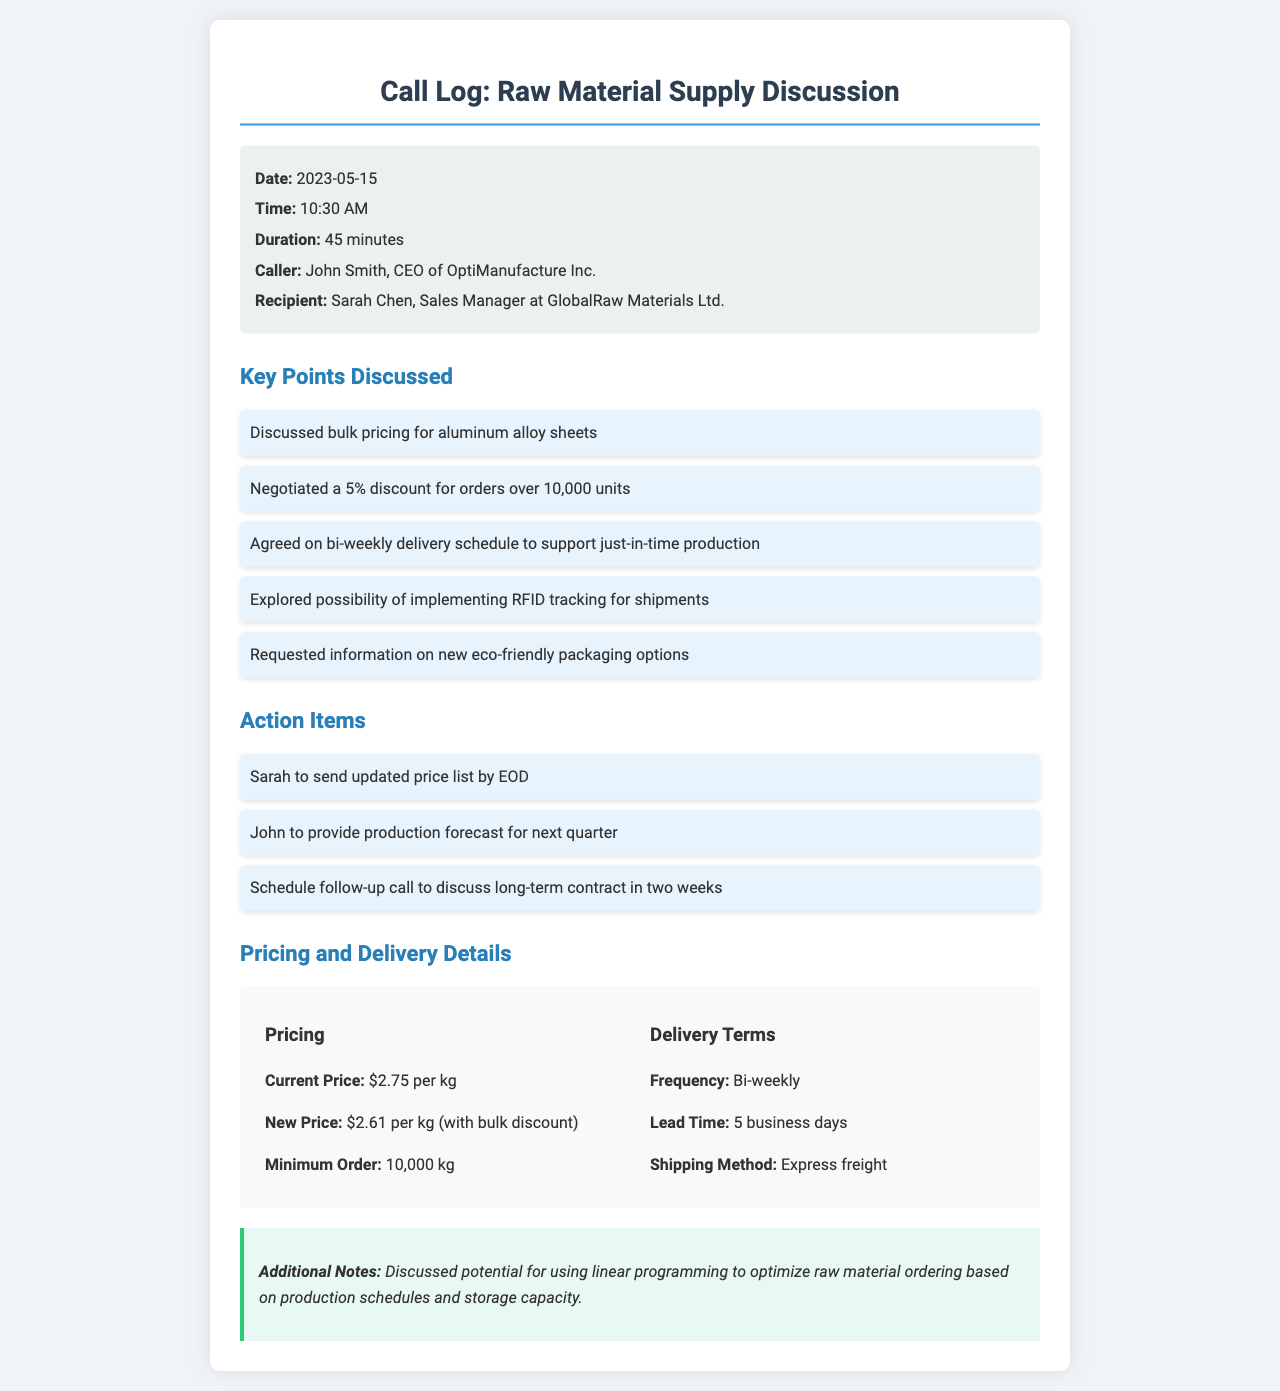What is the date of the call? The date of the call can be found in the call info section of the document.
Answer: 2023-05-15 Who is the CEO of OptiManufacture Inc.? The caller's name and title are specified in the document.
Answer: John Smith What percentage discount was negotiated for bulk orders? This information is discussed under the key points section.
Answer: 5% What is the new price per kg after the bulk discount? The pricing section lists current and new prices.
Answer: $2.61 per kg What is the minimum order quantity specified? This detail is included in the pricing details section.
Answer: 10,000 kg How often are deliveries scheduled? The delivery terms section outlines the frequency of deliveries.
Answer: Bi-weekly What is the lead time for delivery? The lead time is mentioned in the delivery details part of the document.
Answer: 5 business days What action is Sarah required to take? The action items section lists specific tasks each participant must complete.
Answer: Send updated price list by EOD What potential optimization technique was discussed? The additional notes section mentions specific techniques considered for raw material ordering.
Answer: Linear programming 